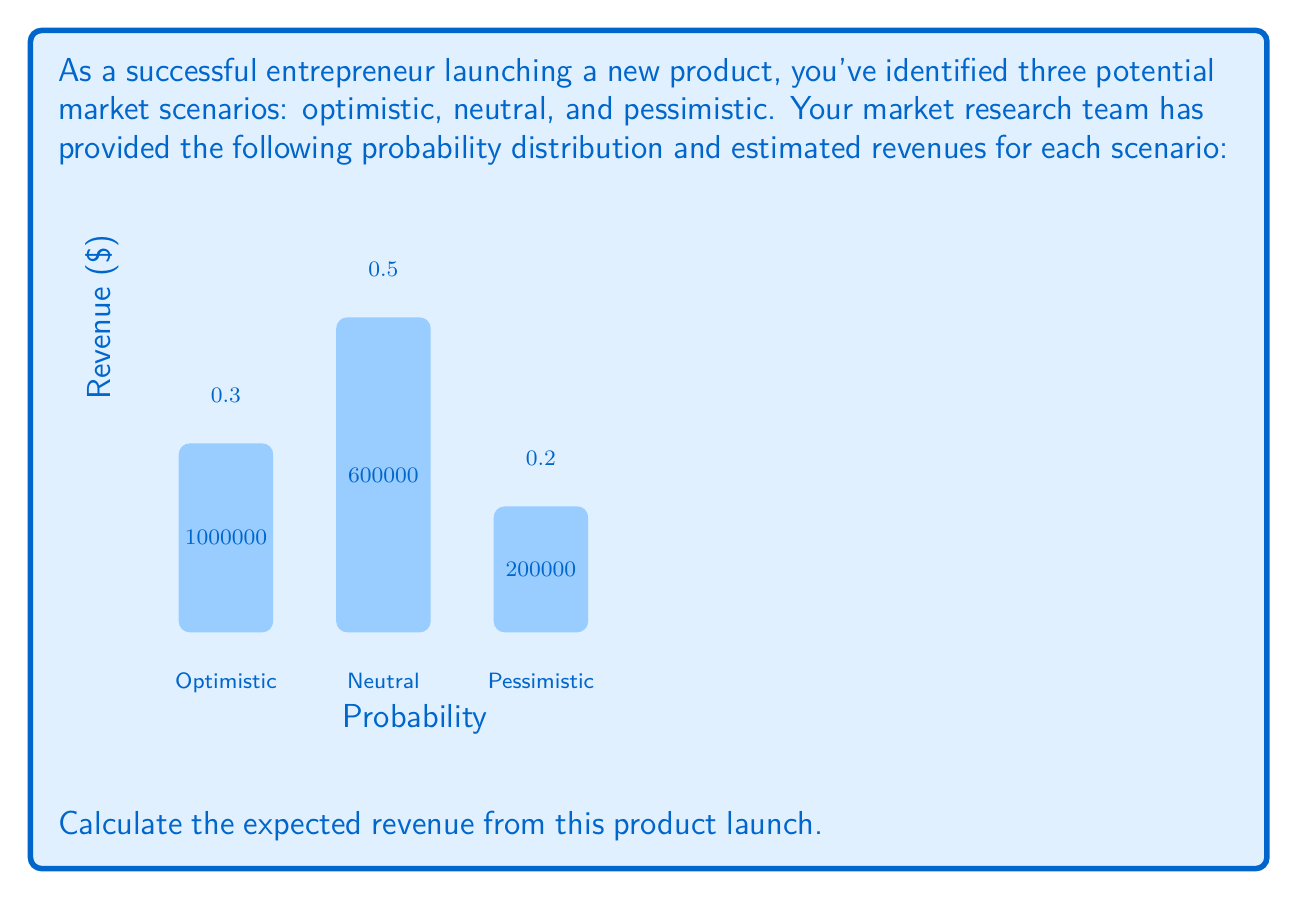Teach me how to tackle this problem. To calculate the expected revenue, we need to multiply each possible revenue outcome by its probability and then sum these products. This is the formula for expected value:

$$ E(X) = \sum_{i=1}^{n} x_i \cdot p(x_i) $$

Where $x_i$ is each possible outcome and $p(x_i)$ is the probability of that outcome.

Let's calculate for each scenario:

1. Optimistic scenario:
   Revenue = $1,000,000, Probability = 0.3
   $1,000,000 \times 0.3 = $300,000

2. Neutral scenario:
   Revenue = $600,000, Probability = 0.5
   $600,000 \times 0.5 = $300,000

3. Pessimistic scenario:
   Revenue = $200,000, Probability = 0.2
   $200,000 \times 0.2 = $40,000

Now, we sum these values:

$$ \text{Expected Revenue} = $300,000 + $300,000 + $40,000 = $640,000 $$

Therefore, the expected revenue from this product launch is $640,000.
Answer: $640,000 